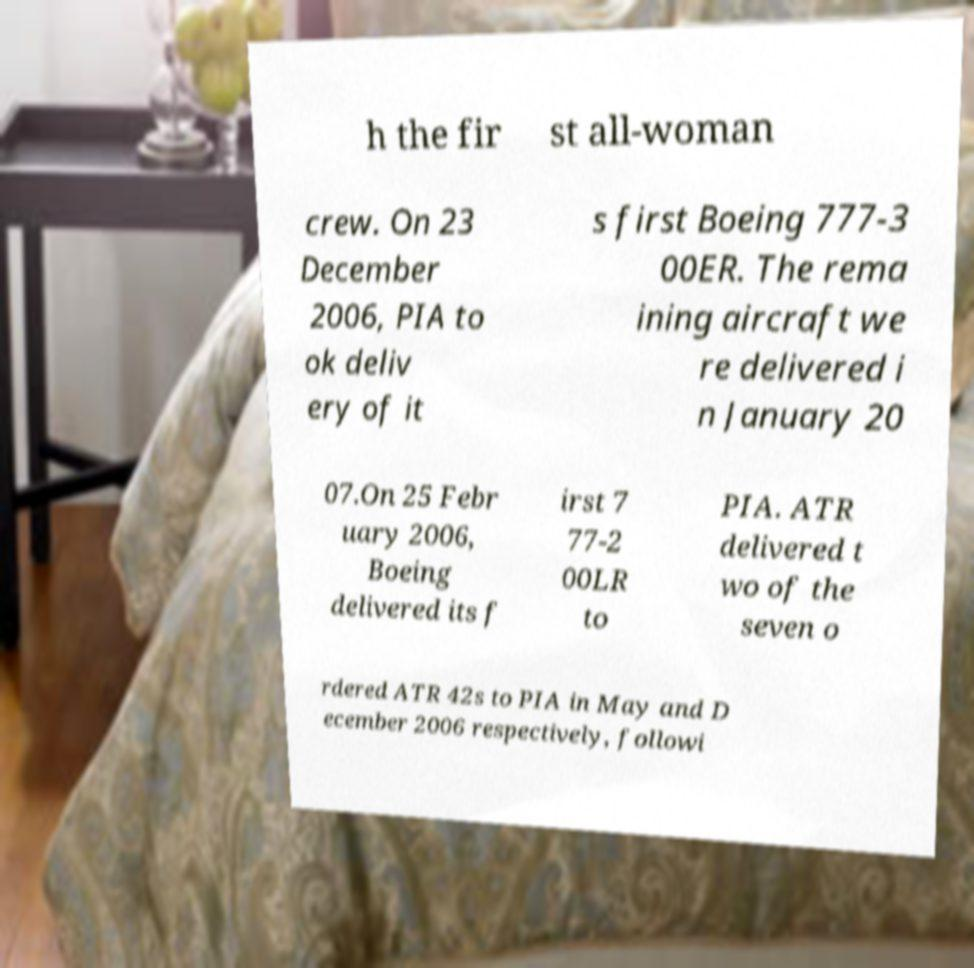I need the written content from this picture converted into text. Can you do that? h the fir st all-woman crew. On 23 December 2006, PIA to ok deliv ery of it s first Boeing 777-3 00ER. The rema ining aircraft we re delivered i n January 20 07.On 25 Febr uary 2006, Boeing delivered its f irst 7 77-2 00LR to PIA. ATR delivered t wo of the seven o rdered ATR 42s to PIA in May and D ecember 2006 respectively, followi 